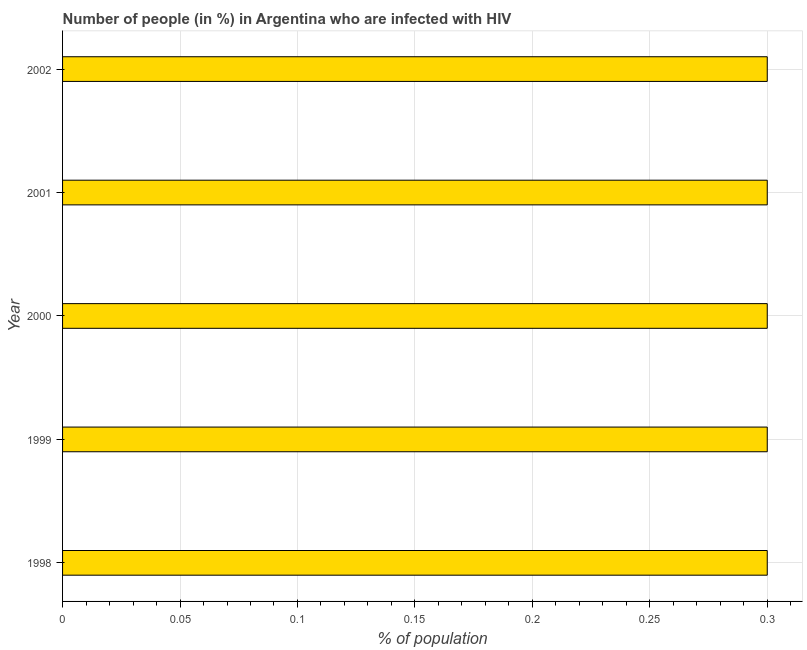Does the graph contain any zero values?
Offer a terse response. No. What is the title of the graph?
Provide a short and direct response. Number of people (in %) in Argentina who are infected with HIV. What is the label or title of the X-axis?
Offer a terse response. % of population. In which year was the number of people infected with hiv minimum?
Offer a very short reply. 1998. What is the sum of the number of people infected with hiv?
Your answer should be very brief. 1.5. What is the difference between the number of people infected with hiv in 1999 and 2001?
Your answer should be compact. 0. What is the median number of people infected with hiv?
Keep it short and to the point. 0.3. Do a majority of the years between 1999 and 1998 (inclusive) have number of people infected with hiv greater than 0.23 %?
Your answer should be very brief. No. What is the ratio of the number of people infected with hiv in 2001 to that in 2002?
Ensure brevity in your answer.  1. Is the difference between the number of people infected with hiv in 1999 and 2002 greater than the difference between any two years?
Make the answer very short. Yes. What is the difference between the highest and the second highest number of people infected with hiv?
Provide a short and direct response. 0. Is the sum of the number of people infected with hiv in 1998 and 1999 greater than the maximum number of people infected with hiv across all years?
Offer a terse response. Yes. How many bars are there?
Ensure brevity in your answer.  5. How many years are there in the graph?
Your response must be concise. 5. Are the values on the major ticks of X-axis written in scientific E-notation?
Provide a succinct answer. No. What is the % of population in 1999?
Keep it short and to the point. 0.3. What is the % of population of 2000?
Ensure brevity in your answer.  0.3. What is the difference between the % of population in 1998 and 2000?
Provide a short and direct response. 0. What is the difference between the % of population in 1998 and 2002?
Offer a terse response. 0. What is the difference between the % of population in 1999 and 2002?
Your answer should be compact. 0. What is the difference between the % of population in 2000 and 2001?
Ensure brevity in your answer.  0. What is the difference between the % of population in 2000 and 2002?
Ensure brevity in your answer.  0. What is the ratio of the % of population in 1998 to that in 2000?
Offer a terse response. 1. What is the ratio of the % of population in 1999 to that in 2002?
Provide a succinct answer. 1. What is the ratio of the % of population in 2000 to that in 2001?
Make the answer very short. 1. What is the ratio of the % of population in 2000 to that in 2002?
Your response must be concise. 1. 